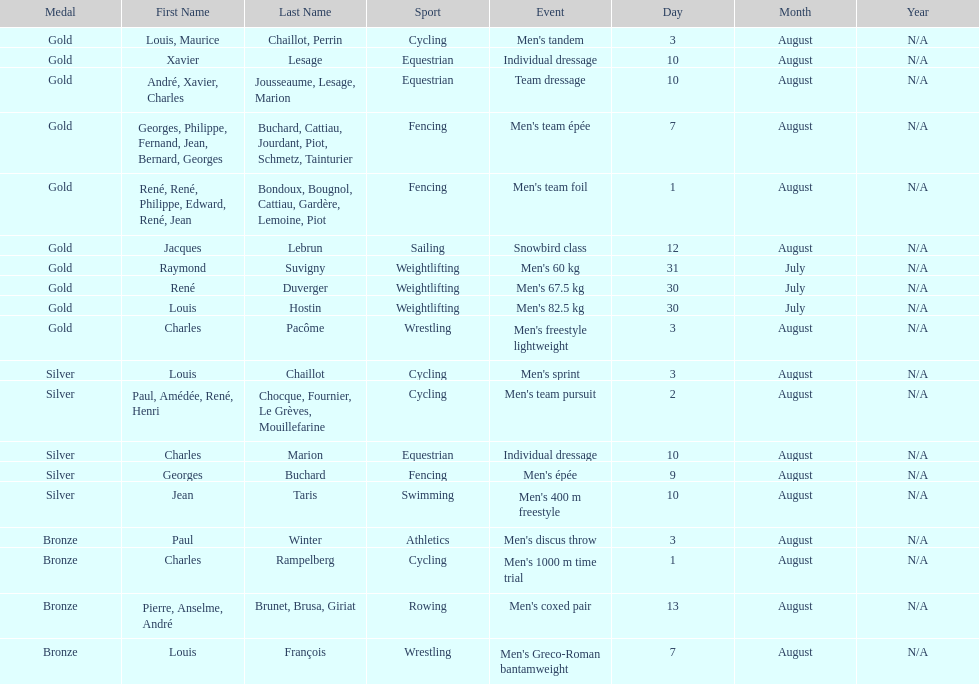Would you be able to parse every entry in this table? {'header': ['Medal', 'First Name', 'Last Name', 'Sport', 'Event', 'Day', 'Month', 'Year'], 'rows': [['Gold', 'Louis, Maurice', 'Chaillot, Perrin', 'Cycling', "Men's tandem", '3', 'August', 'N/A'], ['Gold', 'Xavier', 'Lesage', 'Equestrian', 'Individual dressage', '10', 'August', 'N/A'], ['Gold', 'André, Xavier, Charles', 'Jousseaume, Lesage, Marion', 'Equestrian', 'Team dressage', '10', 'August', 'N/A'], ['Gold', 'Georges, Philippe, Fernand, Jean, Bernard, Georges', 'Buchard, Cattiau, Jourdant, Piot, Schmetz, Tainturier', 'Fencing', "Men's team épée", '7', 'August', 'N/A'], ['Gold', 'René, René, Philippe, Edward, René, Jean', 'Bondoux, Bougnol, Cattiau, Gardère, Lemoine, Piot', 'Fencing', "Men's team foil", '1', 'August', 'N/A'], ['Gold', 'Jacques', 'Lebrun', 'Sailing', 'Snowbird class', '12', 'August', 'N/A'], ['Gold', 'Raymond', 'Suvigny', 'Weightlifting', "Men's 60 kg", '31', 'July', 'N/A'], ['Gold', 'René', 'Duverger', 'Weightlifting', "Men's 67.5 kg", '30', 'July', 'N/A'], ['Gold', 'Louis', 'Hostin', 'Weightlifting', "Men's 82.5 kg", '30', 'July', 'N/A'], ['Gold', 'Charles', 'Pacôme', 'Wrestling', "Men's freestyle lightweight", '3', 'August', 'N/A'], ['Silver', 'Louis', 'Chaillot', 'Cycling', "Men's sprint", '3', 'August', 'N/A'], ['Silver', 'Paul, Amédée, René, Henri', 'Chocque, Fournier, Le Grèves, Mouillefarine', 'Cycling', "Men's team pursuit", '2', 'August', 'N/A'], ['Silver', 'Charles', 'Marion', 'Equestrian', 'Individual dressage', '10', 'August', 'N/A'], ['Silver', 'Georges', 'Buchard', 'Fencing', "Men's épée", '9', 'August', 'N/A'], ['Silver', 'Jean', 'Taris', 'Swimming', "Men's 400 m freestyle", '10', 'August', 'N/A'], ['Bronze', 'Paul', 'Winter', 'Athletics', "Men's discus throw", '3', 'August', 'N/A'], ['Bronze', 'Charles', 'Rampelberg', 'Cycling', "Men's 1000 m time trial", '1', 'August', 'N/A'], ['Bronze', 'Pierre, Anselme, André', 'Brunet, Brusa, Giriat', 'Rowing', "Men's coxed pair", '13', 'August', 'N/A'], ['Bronze', 'Louis', 'François', 'Wrestling', "Men's Greco-Roman bantamweight", '7', 'August', 'N/A']]} How many medals were won after august 3? 9. 